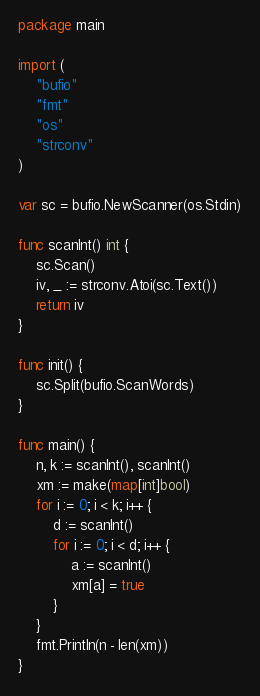Convert code to text. <code><loc_0><loc_0><loc_500><loc_500><_Go_>package main

import (
	"bufio"
	"fmt"
	"os"
	"strconv"
)

var sc = bufio.NewScanner(os.Stdin)

func scanInt() int {
	sc.Scan()
	iv, _ := strconv.Atoi(sc.Text())
	return iv
}

func init() {
	sc.Split(bufio.ScanWords)
}

func main() {
	n, k := scanInt(), scanInt()
	xm := make(map[int]bool)
	for i := 0; i < k; i++ {
		d := scanInt()
		for i := 0; i < d; i++ {
			a := scanInt()
			xm[a] = true
		}
	}
	fmt.Println(n - len(xm))
}
</code> 